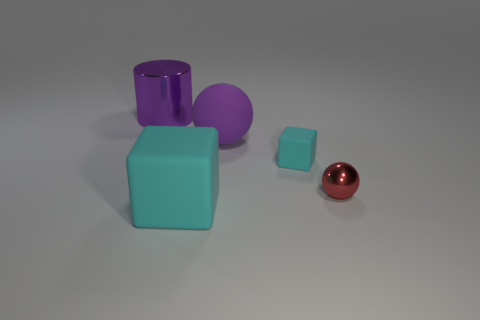Add 4 small red rubber cylinders. How many objects exist? 9 Subtract 1 spheres. How many spheres are left? 1 Subtract 0 brown cylinders. How many objects are left? 5 Subtract all cylinders. How many objects are left? 4 Subtract all purple balls. Subtract all blue blocks. How many balls are left? 1 Subtract all brown cylinders. How many purple balls are left? 1 Subtract all matte balls. Subtract all spheres. How many objects are left? 2 Add 3 metal things. How many metal things are left? 5 Add 2 purple shiny cylinders. How many purple shiny cylinders exist? 3 